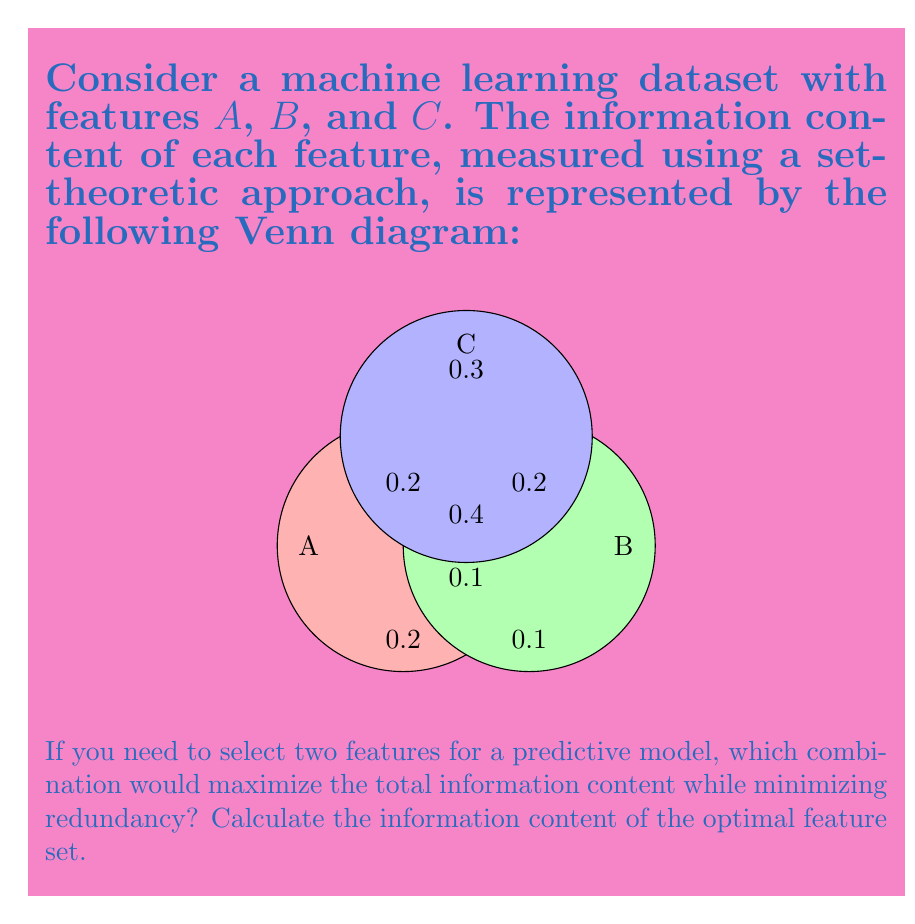Solve this math problem. To solve this problem, we need to consider the information content of each possible pair of features while accounting for their overlap (redundancy). Let's approach this step-by-step:

1) First, let's calculate the total information content for each pair of features:

   For A and B:
   $$I(A,B) = 0.2 + 0.1 + 0.1 + 0.4 + 0.1 = 0.9$$

   For A and C:
   $$I(A,C) = 0.2 + 0.3 + 0.2 + 0.4 + 0.2 = 1.3$$

   For B and C:
   $$I(B,C) = 0.1 + 0.3 + 0.2 + 0.4 + 0.2 = 1.2$$

2) Now, we need to consider the redundancy in each pair. The redundancy is represented by the overlap between the two features:

   For A and B: 0.1 + 0.4 = 0.5
   For A and C: 0.2 + 0.4 = 0.6
   For B and C: 0.2 + 0.4 = 0.6

3) To maximize information content while minimizing redundancy, we want the pair with the highest total information content and the lowest redundancy.

4) Comparing the pairs:
   A and B: Total = 0.9, Redundancy = 0.5
   A and C: Total = 1.3, Redundancy = 0.6
   B and C: Total = 1.2, Redundancy = 0.6

5) A and C have the highest total information content (1.3). While they have slightly more redundancy than A and B, their total information content is significantly higher, making them the optimal choice.

6) The information content of the optimal feature set (A and C) is 1.3.
Answer: Features A and C; Information content: 1.3 